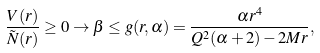Convert formula to latex. <formula><loc_0><loc_0><loc_500><loc_500>\frac { V ( r ) } { \tilde { N } ( r ) } \geq 0 \to \beta \leq g ( r , \alpha ) = \frac { \alpha r ^ { 4 } } { Q ^ { 2 } ( \alpha + 2 ) - 2 M r } ,</formula> 